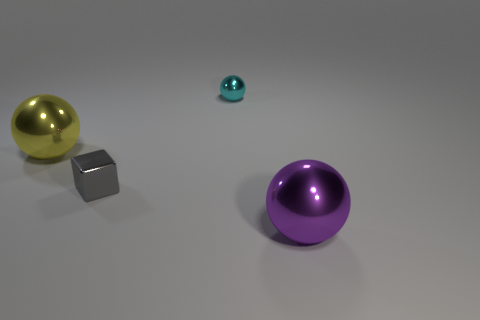How does the reflective surface of the gray cube compare to the shininess of the purple ball? The gray cube's surface has a reflective quality with a slightly matte finish, which contrasts with the highly polished, mirror-like sheen of the purple ball. This difference in texture highlights the unique physical properties of each object. 